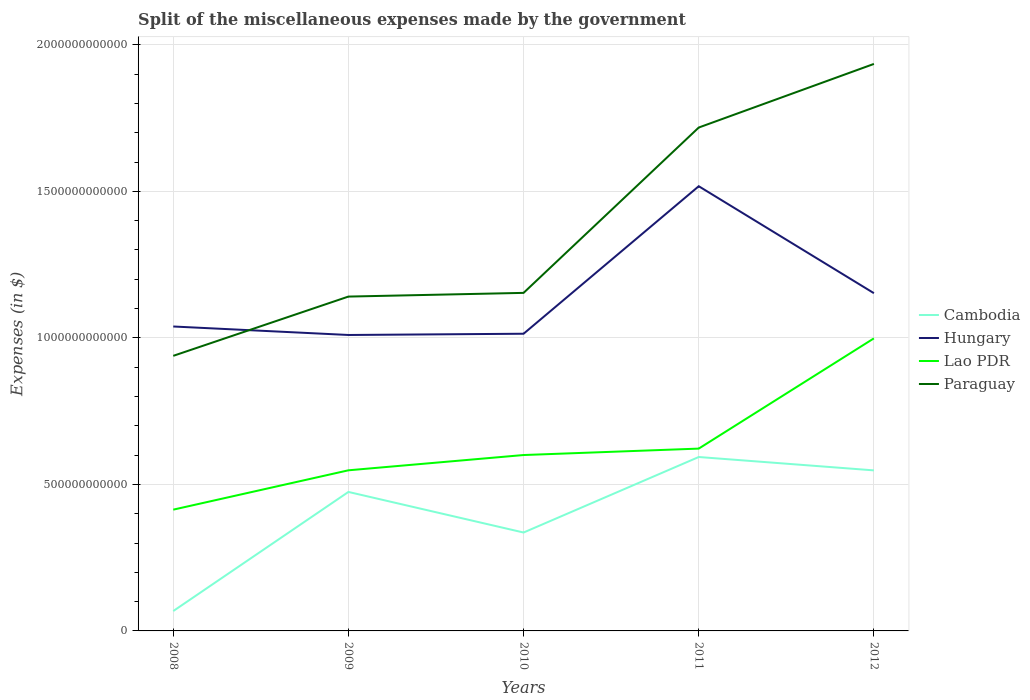Does the line corresponding to Lao PDR intersect with the line corresponding to Paraguay?
Make the answer very short. No. Is the number of lines equal to the number of legend labels?
Make the answer very short. Yes. Across all years, what is the maximum miscellaneous expenses made by the government in Paraguay?
Offer a very short reply. 9.39e+11. What is the total miscellaneous expenses made by the government in Cambodia in the graph?
Ensure brevity in your answer.  -5.26e+11. What is the difference between the highest and the second highest miscellaneous expenses made by the government in Cambodia?
Offer a terse response. 5.26e+11. Is the miscellaneous expenses made by the government in Paraguay strictly greater than the miscellaneous expenses made by the government in Lao PDR over the years?
Offer a terse response. No. How many years are there in the graph?
Your response must be concise. 5. What is the difference between two consecutive major ticks on the Y-axis?
Your answer should be very brief. 5.00e+11. Are the values on the major ticks of Y-axis written in scientific E-notation?
Give a very brief answer. No. Does the graph contain any zero values?
Provide a short and direct response. No. Where does the legend appear in the graph?
Offer a very short reply. Center right. How are the legend labels stacked?
Provide a short and direct response. Vertical. What is the title of the graph?
Offer a very short reply. Split of the miscellaneous expenses made by the government. What is the label or title of the X-axis?
Your answer should be very brief. Years. What is the label or title of the Y-axis?
Ensure brevity in your answer.  Expenses (in $). What is the Expenses (in $) of Cambodia in 2008?
Give a very brief answer. 6.78e+1. What is the Expenses (in $) of Hungary in 2008?
Offer a terse response. 1.04e+12. What is the Expenses (in $) of Lao PDR in 2008?
Offer a very short reply. 4.14e+11. What is the Expenses (in $) of Paraguay in 2008?
Your answer should be compact. 9.39e+11. What is the Expenses (in $) in Cambodia in 2009?
Ensure brevity in your answer.  4.74e+11. What is the Expenses (in $) of Hungary in 2009?
Your response must be concise. 1.01e+12. What is the Expenses (in $) of Lao PDR in 2009?
Your response must be concise. 5.48e+11. What is the Expenses (in $) of Paraguay in 2009?
Give a very brief answer. 1.14e+12. What is the Expenses (in $) of Cambodia in 2010?
Give a very brief answer. 3.36e+11. What is the Expenses (in $) in Hungary in 2010?
Offer a terse response. 1.01e+12. What is the Expenses (in $) in Lao PDR in 2010?
Provide a short and direct response. 6.00e+11. What is the Expenses (in $) in Paraguay in 2010?
Ensure brevity in your answer.  1.15e+12. What is the Expenses (in $) of Cambodia in 2011?
Give a very brief answer. 5.93e+11. What is the Expenses (in $) in Hungary in 2011?
Keep it short and to the point. 1.52e+12. What is the Expenses (in $) in Lao PDR in 2011?
Your answer should be compact. 6.22e+11. What is the Expenses (in $) in Paraguay in 2011?
Offer a very short reply. 1.72e+12. What is the Expenses (in $) of Cambodia in 2012?
Your answer should be compact. 5.48e+11. What is the Expenses (in $) of Hungary in 2012?
Provide a succinct answer. 1.15e+12. What is the Expenses (in $) in Lao PDR in 2012?
Provide a short and direct response. 9.98e+11. What is the Expenses (in $) of Paraguay in 2012?
Keep it short and to the point. 1.93e+12. Across all years, what is the maximum Expenses (in $) of Cambodia?
Offer a very short reply. 5.93e+11. Across all years, what is the maximum Expenses (in $) in Hungary?
Your answer should be very brief. 1.52e+12. Across all years, what is the maximum Expenses (in $) in Lao PDR?
Make the answer very short. 9.98e+11. Across all years, what is the maximum Expenses (in $) of Paraguay?
Your response must be concise. 1.93e+12. Across all years, what is the minimum Expenses (in $) in Cambodia?
Give a very brief answer. 6.78e+1. Across all years, what is the minimum Expenses (in $) of Hungary?
Ensure brevity in your answer.  1.01e+12. Across all years, what is the minimum Expenses (in $) of Lao PDR?
Provide a short and direct response. 4.14e+11. Across all years, what is the minimum Expenses (in $) of Paraguay?
Your response must be concise. 9.39e+11. What is the total Expenses (in $) in Cambodia in the graph?
Your answer should be compact. 2.02e+12. What is the total Expenses (in $) in Hungary in the graph?
Your answer should be very brief. 5.73e+12. What is the total Expenses (in $) of Lao PDR in the graph?
Give a very brief answer. 3.18e+12. What is the total Expenses (in $) of Paraguay in the graph?
Offer a very short reply. 6.89e+12. What is the difference between the Expenses (in $) of Cambodia in 2008 and that in 2009?
Make the answer very short. -4.06e+11. What is the difference between the Expenses (in $) of Hungary in 2008 and that in 2009?
Provide a succinct answer. 2.90e+1. What is the difference between the Expenses (in $) of Lao PDR in 2008 and that in 2009?
Ensure brevity in your answer.  -1.34e+11. What is the difference between the Expenses (in $) of Paraguay in 2008 and that in 2009?
Your answer should be compact. -2.02e+11. What is the difference between the Expenses (in $) in Cambodia in 2008 and that in 2010?
Your answer should be compact. -2.68e+11. What is the difference between the Expenses (in $) of Hungary in 2008 and that in 2010?
Keep it short and to the point. 2.47e+1. What is the difference between the Expenses (in $) of Lao PDR in 2008 and that in 2010?
Provide a short and direct response. -1.86e+11. What is the difference between the Expenses (in $) of Paraguay in 2008 and that in 2010?
Offer a very short reply. -2.15e+11. What is the difference between the Expenses (in $) in Cambodia in 2008 and that in 2011?
Make the answer very short. -5.26e+11. What is the difference between the Expenses (in $) in Hungary in 2008 and that in 2011?
Make the answer very short. -4.79e+11. What is the difference between the Expenses (in $) in Lao PDR in 2008 and that in 2011?
Your answer should be compact. -2.08e+11. What is the difference between the Expenses (in $) in Paraguay in 2008 and that in 2011?
Keep it short and to the point. -7.79e+11. What is the difference between the Expenses (in $) of Cambodia in 2008 and that in 2012?
Provide a short and direct response. -4.80e+11. What is the difference between the Expenses (in $) in Hungary in 2008 and that in 2012?
Offer a very short reply. -1.14e+11. What is the difference between the Expenses (in $) in Lao PDR in 2008 and that in 2012?
Offer a terse response. -5.85e+11. What is the difference between the Expenses (in $) of Paraguay in 2008 and that in 2012?
Make the answer very short. -9.96e+11. What is the difference between the Expenses (in $) of Cambodia in 2009 and that in 2010?
Offer a very short reply. 1.38e+11. What is the difference between the Expenses (in $) in Hungary in 2009 and that in 2010?
Provide a short and direct response. -4.23e+09. What is the difference between the Expenses (in $) in Lao PDR in 2009 and that in 2010?
Provide a short and direct response. -5.21e+1. What is the difference between the Expenses (in $) of Paraguay in 2009 and that in 2010?
Your answer should be compact. -1.26e+1. What is the difference between the Expenses (in $) of Cambodia in 2009 and that in 2011?
Keep it short and to the point. -1.19e+11. What is the difference between the Expenses (in $) in Hungary in 2009 and that in 2011?
Your response must be concise. -5.08e+11. What is the difference between the Expenses (in $) in Lao PDR in 2009 and that in 2011?
Your response must be concise. -7.41e+1. What is the difference between the Expenses (in $) in Paraguay in 2009 and that in 2011?
Ensure brevity in your answer.  -5.77e+11. What is the difference between the Expenses (in $) of Cambodia in 2009 and that in 2012?
Ensure brevity in your answer.  -7.35e+1. What is the difference between the Expenses (in $) in Hungary in 2009 and that in 2012?
Offer a terse response. -1.43e+11. What is the difference between the Expenses (in $) of Lao PDR in 2009 and that in 2012?
Your response must be concise. -4.50e+11. What is the difference between the Expenses (in $) of Paraguay in 2009 and that in 2012?
Ensure brevity in your answer.  -7.94e+11. What is the difference between the Expenses (in $) in Cambodia in 2010 and that in 2011?
Provide a succinct answer. -2.58e+11. What is the difference between the Expenses (in $) of Hungary in 2010 and that in 2011?
Provide a succinct answer. -5.03e+11. What is the difference between the Expenses (in $) of Lao PDR in 2010 and that in 2011?
Offer a terse response. -2.19e+1. What is the difference between the Expenses (in $) of Paraguay in 2010 and that in 2011?
Make the answer very short. -5.64e+11. What is the difference between the Expenses (in $) of Cambodia in 2010 and that in 2012?
Ensure brevity in your answer.  -2.12e+11. What is the difference between the Expenses (in $) in Hungary in 2010 and that in 2012?
Keep it short and to the point. -1.38e+11. What is the difference between the Expenses (in $) in Lao PDR in 2010 and that in 2012?
Provide a succinct answer. -3.98e+11. What is the difference between the Expenses (in $) in Paraguay in 2010 and that in 2012?
Offer a terse response. -7.81e+11. What is the difference between the Expenses (in $) of Cambodia in 2011 and that in 2012?
Keep it short and to the point. 4.56e+1. What is the difference between the Expenses (in $) in Hungary in 2011 and that in 2012?
Your answer should be very brief. 3.65e+11. What is the difference between the Expenses (in $) of Lao PDR in 2011 and that in 2012?
Provide a succinct answer. -3.76e+11. What is the difference between the Expenses (in $) in Paraguay in 2011 and that in 2012?
Your answer should be compact. -2.17e+11. What is the difference between the Expenses (in $) of Cambodia in 2008 and the Expenses (in $) of Hungary in 2009?
Offer a very short reply. -9.42e+11. What is the difference between the Expenses (in $) of Cambodia in 2008 and the Expenses (in $) of Lao PDR in 2009?
Your answer should be very brief. -4.80e+11. What is the difference between the Expenses (in $) of Cambodia in 2008 and the Expenses (in $) of Paraguay in 2009?
Your response must be concise. -1.07e+12. What is the difference between the Expenses (in $) of Hungary in 2008 and the Expenses (in $) of Lao PDR in 2009?
Your answer should be compact. 4.91e+11. What is the difference between the Expenses (in $) of Hungary in 2008 and the Expenses (in $) of Paraguay in 2009?
Make the answer very short. -1.02e+11. What is the difference between the Expenses (in $) of Lao PDR in 2008 and the Expenses (in $) of Paraguay in 2009?
Make the answer very short. -7.27e+11. What is the difference between the Expenses (in $) in Cambodia in 2008 and the Expenses (in $) in Hungary in 2010?
Ensure brevity in your answer.  -9.46e+11. What is the difference between the Expenses (in $) in Cambodia in 2008 and the Expenses (in $) in Lao PDR in 2010?
Your answer should be very brief. -5.32e+11. What is the difference between the Expenses (in $) of Cambodia in 2008 and the Expenses (in $) of Paraguay in 2010?
Provide a succinct answer. -1.09e+12. What is the difference between the Expenses (in $) of Hungary in 2008 and the Expenses (in $) of Lao PDR in 2010?
Offer a terse response. 4.39e+11. What is the difference between the Expenses (in $) of Hungary in 2008 and the Expenses (in $) of Paraguay in 2010?
Make the answer very short. -1.15e+11. What is the difference between the Expenses (in $) in Lao PDR in 2008 and the Expenses (in $) in Paraguay in 2010?
Offer a very short reply. -7.40e+11. What is the difference between the Expenses (in $) of Cambodia in 2008 and the Expenses (in $) of Hungary in 2011?
Offer a terse response. -1.45e+12. What is the difference between the Expenses (in $) in Cambodia in 2008 and the Expenses (in $) in Lao PDR in 2011?
Your answer should be compact. -5.54e+11. What is the difference between the Expenses (in $) of Cambodia in 2008 and the Expenses (in $) of Paraguay in 2011?
Offer a very short reply. -1.65e+12. What is the difference between the Expenses (in $) of Hungary in 2008 and the Expenses (in $) of Lao PDR in 2011?
Ensure brevity in your answer.  4.17e+11. What is the difference between the Expenses (in $) of Hungary in 2008 and the Expenses (in $) of Paraguay in 2011?
Give a very brief answer. -6.79e+11. What is the difference between the Expenses (in $) of Lao PDR in 2008 and the Expenses (in $) of Paraguay in 2011?
Provide a succinct answer. -1.30e+12. What is the difference between the Expenses (in $) of Cambodia in 2008 and the Expenses (in $) of Hungary in 2012?
Ensure brevity in your answer.  -1.08e+12. What is the difference between the Expenses (in $) in Cambodia in 2008 and the Expenses (in $) in Lao PDR in 2012?
Your answer should be very brief. -9.31e+11. What is the difference between the Expenses (in $) of Cambodia in 2008 and the Expenses (in $) of Paraguay in 2012?
Keep it short and to the point. -1.87e+12. What is the difference between the Expenses (in $) in Hungary in 2008 and the Expenses (in $) in Lao PDR in 2012?
Offer a very short reply. 4.05e+1. What is the difference between the Expenses (in $) of Hungary in 2008 and the Expenses (in $) of Paraguay in 2012?
Your response must be concise. -8.96e+11. What is the difference between the Expenses (in $) of Lao PDR in 2008 and the Expenses (in $) of Paraguay in 2012?
Offer a terse response. -1.52e+12. What is the difference between the Expenses (in $) of Cambodia in 2009 and the Expenses (in $) of Hungary in 2010?
Keep it short and to the point. -5.40e+11. What is the difference between the Expenses (in $) of Cambodia in 2009 and the Expenses (in $) of Lao PDR in 2010?
Offer a terse response. -1.26e+11. What is the difference between the Expenses (in $) in Cambodia in 2009 and the Expenses (in $) in Paraguay in 2010?
Offer a terse response. -6.79e+11. What is the difference between the Expenses (in $) in Hungary in 2009 and the Expenses (in $) in Lao PDR in 2010?
Provide a succinct answer. 4.10e+11. What is the difference between the Expenses (in $) in Hungary in 2009 and the Expenses (in $) in Paraguay in 2010?
Offer a very short reply. -1.44e+11. What is the difference between the Expenses (in $) of Lao PDR in 2009 and the Expenses (in $) of Paraguay in 2010?
Your answer should be compact. -6.05e+11. What is the difference between the Expenses (in $) of Cambodia in 2009 and the Expenses (in $) of Hungary in 2011?
Make the answer very short. -1.04e+12. What is the difference between the Expenses (in $) in Cambodia in 2009 and the Expenses (in $) in Lao PDR in 2011?
Give a very brief answer. -1.48e+11. What is the difference between the Expenses (in $) of Cambodia in 2009 and the Expenses (in $) of Paraguay in 2011?
Offer a very short reply. -1.24e+12. What is the difference between the Expenses (in $) of Hungary in 2009 and the Expenses (in $) of Lao PDR in 2011?
Your answer should be very brief. 3.88e+11. What is the difference between the Expenses (in $) of Hungary in 2009 and the Expenses (in $) of Paraguay in 2011?
Your answer should be very brief. -7.08e+11. What is the difference between the Expenses (in $) in Lao PDR in 2009 and the Expenses (in $) in Paraguay in 2011?
Ensure brevity in your answer.  -1.17e+12. What is the difference between the Expenses (in $) of Cambodia in 2009 and the Expenses (in $) of Hungary in 2012?
Provide a short and direct response. -6.78e+11. What is the difference between the Expenses (in $) in Cambodia in 2009 and the Expenses (in $) in Lao PDR in 2012?
Provide a succinct answer. -5.24e+11. What is the difference between the Expenses (in $) of Cambodia in 2009 and the Expenses (in $) of Paraguay in 2012?
Provide a short and direct response. -1.46e+12. What is the difference between the Expenses (in $) of Hungary in 2009 and the Expenses (in $) of Lao PDR in 2012?
Make the answer very short. 1.15e+1. What is the difference between the Expenses (in $) of Hungary in 2009 and the Expenses (in $) of Paraguay in 2012?
Provide a succinct answer. -9.25e+11. What is the difference between the Expenses (in $) of Lao PDR in 2009 and the Expenses (in $) of Paraguay in 2012?
Provide a succinct answer. -1.39e+12. What is the difference between the Expenses (in $) of Cambodia in 2010 and the Expenses (in $) of Hungary in 2011?
Keep it short and to the point. -1.18e+12. What is the difference between the Expenses (in $) in Cambodia in 2010 and the Expenses (in $) in Lao PDR in 2011?
Ensure brevity in your answer.  -2.86e+11. What is the difference between the Expenses (in $) of Cambodia in 2010 and the Expenses (in $) of Paraguay in 2011?
Your answer should be compact. -1.38e+12. What is the difference between the Expenses (in $) in Hungary in 2010 and the Expenses (in $) in Lao PDR in 2011?
Your answer should be compact. 3.92e+11. What is the difference between the Expenses (in $) of Hungary in 2010 and the Expenses (in $) of Paraguay in 2011?
Ensure brevity in your answer.  -7.04e+11. What is the difference between the Expenses (in $) in Lao PDR in 2010 and the Expenses (in $) in Paraguay in 2011?
Provide a short and direct response. -1.12e+12. What is the difference between the Expenses (in $) of Cambodia in 2010 and the Expenses (in $) of Hungary in 2012?
Provide a short and direct response. -8.17e+11. What is the difference between the Expenses (in $) of Cambodia in 2010 and the Expenses (in $) of Lao PDR in 2012?
Give a very brief answer. -6.63e+11. What is the difference between the Expenses (in $) in Cambodia in 2010 and the Expenses (in $) in Paraguay in 2012?
Ensure brevity in your answer.  -1.60e+12. What is the difference between the Expenses (in $) of Hungary in 2010 and the Expenses (in $) of Lao PDR in 2012?
Your answer should be compact. 1.58e+1. What is the difference between the Expenses (in $) in Hungary in 2010 and the Expenses (in $) in Paraguay in 2012?
Keep it short and to the point. -9.21e+11. What is the difference between the Expenses (in $) of Lao PDR in 2010 and the Expenses (in $) of Paraguay in 2012?
Your response must be concise. -1.33e+12. What is the difference between the Expenses (in $) in Cambodia in 2011 and the Expenses (in $) in Hungary in 2012?
Provide a succinct answer. -5.59e+11. What is the difference between the Expenses (in $) of Cambodia in 2011 and the Expenses (in $) of Lao PDR in 2012?
Ensure brevity in your answer.  -4.05e+11. What is the difference between the Expenses (in $) in Cambodia in 2011 and the Expenses (in $) in Paraguay in 2012?
Offer a terse response. -1.34e+12. What is the difference between the Expenses (in $) in Hungary in 2011 and the Expenses (in $) in Lao PDR in 2012?
Make the answer very short. 5.19e+11. What is the difference between the Expenses (in $) of Hungary in 2011 and the Expenses (in $) of Paraguay in 2012?
Keep it short and to the point. -4.17e+11. What is the difference between the Expenses (in $) of Lao PDR in 2011 and the Expenses (in $) of Paraguay in 2012?
Your answer should be compact. -1.31e+12. What is the average Expenses (in $) of Cambodia per year?
Your answer should be compact. 4.04e+11. What is the average Expenses (in $) of Hungary per year?
Give a very brief answer. 1.15e+12. What is the average Expenses (in $) of Lao PDR per year?
Offer a very short reply. 6.37e+11. What is the average Expenses (in $) of Paraguay per year?
Ensure brevity in your answer.  1.38e+12. In the year 2008, what is the difference between the Expenses (in $) of Cambodia and Expenses (in $) of Hungary?
Your answer should be very brief. -9.71e+11. In the year 2008, what is the difference between the Expenses (in $) in Cambodia and Expenses (in $) in Lao PDR?
Provide a short and direct response. -3.46e+11. In the year 2008, what is the difference between the Expenses (in $) in Cambodia and Expenses (in $) in Paraguay?
Offer a very short reply. -8.71e+11. In the year 2008, what is the difference between the Expenses (in $) in Hungary and Expenses (in $) in Lao PDR?
Keep it short and to the point. 6.25e+11. In the year 2008, what is the difference between the Expenses (in $) in Hungary and Expenses (in $) in Paraguay?
Offer a very short reply. 1.00e+11. In the year 2008, what is the difference between the Expenses (in $) in Lao PDR and Expenses (in $) in Paraguay?
Offer a very short reply. -5.25e+11. In the year 2009, what is the difference between the Expenses (in $) in Cambodia and Expenses (in $) in Hungary?
Provide a short and direct response. -5.36e+11. In the year 2009, what is the difference between the Expenses (in $) of Cambodia and Expenses (in $) of Lao PDR?
Your answer should be compact. -7.38e+1. In the year 2009, what is the difference between the Expenses (in $) in Cambodia and Expenses (in $) in Paraguay?
Keep it short and to the point. -6.67e+11. In the year 2009, what is the difference between the Expenses (in $) of Hungary and Expenses (in $) of Lao PDR?
Provide a short and direct response. 4.62e+11. In the year 2009, what is the difference between the Expenses (in $) of Hungary and Expenses (in $) of Paraguay?
Provide a short and direct response. -1.31e+11. In the year 2009, what is the difference between the Expenses (in $) of Lao PDR and Expenses (in $) of Paraguay?
Make the answer very short. -5.93e+11. In the year 2010, what is the difference between the Expenses (in $) of Cambodia and Expenses (in $) of Hungary?
Offer a terse response. -6.78e+11. In the year 2010, what is the difference between the Expenses (in $) in Cambodia and Expenses (in $) in Lao PDR?
Provide a short and direct response. -2.64e+11. In the year 2010, what is the difference between the Expenses (in $) in Cambodia and Expenses (in $) in Paraguay?
Give a very brief answer. -8.18e+11. In the year 2010, what is the difference between the Expenses (in $) of Hungary and Expenses (in $) of Lao PDR?
Your answer should be compact. 4.14e+11. In the year 2010, what is the difference between the Expenses (in $) of Hungary and Expenses (in $) of Paraguay?
Provide a succinct answer. -1.39e+11. In the year 2010, what is the difference between the Expenses (in $) of Lao PDR and Expenses (in $) of Paraguay?
Offer a terse response. -5.53e+11. In the year 2011, what is the difference between the Expenses (in $) in Cambodia and Expenses (in $) in Hungary?
Ensure brevity in your answer.  -9.24e+11. In the year 2011, what is the difference between the Expenses (in $) in Cambodia and Expenses (in $) in Lao PDR?
Provide a short and direct response. -2.87e+1. In the year 2011, what is the difference between the Expenses (in $) of Cambodia and Expenses (in $) of Paraguay?
Make the answer very short. -1.12e+12. In the year 2011, what is the difference between the Expenses (in $) in Hungary and Expenses (in $) in Lao PDR?
Keep it short and to the point. 8.95e+11. In the year 2011, what is the difference between the Expenses (in $) of Hungary and Expenses (in $) of Paraguay?
Offer a very short reply. -2.00e+11. In the year 2011, what is the difference between the Expenses (in $) of Lao PDR and Expenses (in $) of Paraguay?
Offer a terse response. -1.10e+12. In the year 2012, what is the difference between the Expenses (in $) in Cambodia and Expenses (in $) in Hungary?
Your answer should be very brief. -6.05e+11. In the year 2012, what is the difference between the Expenses (in $) of Cambodia and Expenses (in $) of Lao PDR?
Your answer should be very brief. -4.51e+11. In the year 2012, what is the difference between the Expenses (in $) of Cambodia and Expenses (in $) of Paraguay?
Offer a very short reply. -1.39e+12. In the year 2012, what is the difference between the Expenses (in $) of Hungary and Expenses (in $) of Lao PDR?
Provide a succinct answer. 1.54e+11. In the year 2012, what is the difference between the Expenses (in $) of Hungary and Expenses (in $) of Paraguay?
Make the answer very short. -7.82e+11. In the year 2012, what is the difference between the Expenses (in $) in Lao PDR and Expenses (in $) in Paraguay?
Your answer should be very brief. -9.36e+11. What is the ratio of the Expenses (in $) of Cambodia in 2008 to that in 2009?
Offer a terse response. 0.14. What is the ratio of the Expenses (in $) in Hungary in 2008 to that in 2009?
Your answer should be compact. 1.03. What is the ratio of the Expenses (in $) in Lao PDR in 2008 to that in 2009?
Your response must be concise. 0.76. What is the ratio of the Expenses (in $) in Paraguay in 2008 to that in 2009?
Provide a succinct answer. 0.82. What is the ratio of the Expenses (in $) of Cambodia in 2008 to that in 2010?
Keep it short and to the point. 0.2. What is the ratio of the Expenses (in $) of Hungary in 2008 to that in 2010?
Your answer should be compact. 1.02. What is the ratio of the Expenses (in $) in Lao PDR in 2008 to that in 2010?
Your response must be concise. 0.69. What is the ratio of the Expenses (in $) in Paraguay in 2008 to that in 2010?
Your answer should be very brief. 0.81. What is the ratio of the Expenses (in $) in Cambodia in 2008 to that in 2011?
Your answer should be compact. 0.11. What is the ratio of the Expenses (in $) of Hungary in 2008 to that in 2011?
Keep it short and to the point. 0.68. What is the ratio of the Expenses (in $) in Lao PDR in 2008 to that in 2011?
Your answer should be compact. 0.67. What is the ratio of the Expenses (in $) of Paraguay in 2008 to that in 2011?
Provide a succinct answer. 0.55. What is the ratio of the Expenses (in $) of Cambodia in 2008 to that in 2012?
Provide a short and direct response. 0.12. What is the ratio of the Expenses (in $) of Hungary in 2008 to that in 2012?
Your answer should be very brief. 0.9. What is the ratio of the Expenses (in $) of Lao PDR in 2008 to that in 2012?
Provide a succinct answer. 0.41. What is the ratio of the Expenses (in $) of Paraguay in 2008 to that in 2012?
Provide a short and direct response. 0.49. What is the ratio of the Expenses (in $) in Cambodia in 2009 to that in 2010?
Keep it short and to the point. 1.41. What is the ratio of the Expenses (in $) of Lao PDR in 2009 to that in 2010?
Offer a terse response. 0.91. What is the ratio of the Expenses (in $) in Cambodia in 2009 to that in 2011?
Your answer should be very brief. 0.8. What is the ratio of the Expenses (in $) of Hungary in 2009 to that in 2011?
Offer a very short reply. 0.67. What is the ratio of the Expenses (in $) of Lao PDR in 2009 to that in 2011?
Your answer should be compact. 0.88. What is the ratio of the Expenses (in $) in Paraguay in 2009 to that in 2011?
Make the answer very short. 0.66. What is the ratio of the Expenses (in $) in Cambodia in 2009 to that in 2012?
Provide a succinct answer. 0.87. What is the ratio of the Expenses (in $) of Hungary in 2009 to that in 2012?
Give a very brief answer. 0.88. What is the ratio of the Expenses (in $) in Lao PDR in 2009 to that in 2012?
Your answer should be compact. 0.55. What is the ratio of the Expenses (in $) in Paraguay in 2009 to that in 2012?
Your answer should be compact. 0.59. What is the ratio of the Expenses (in $) of Cambodia in 2010 to that in 2011?
Your answer should be compact. 0.57. What is the ratio of the Expenses (in $) of Hungary in 2010 to that in 2011?
Keep it short and to the point. 0.67. What is the ratio of the Expenses (in $) of Lao PDR in 2010 to that in 2011?
Your answer should be compact. 0.96. What is the ratio of the Expenses (in $) of Paraguay in 2010 to that in 2011?
Keep it short and to the point. 0.67. What is the ratio of the Expenses (in $) in Cambodia in 2010 to that in 2012?
Ensure brevity in your answer.  0.61. What is the ratio of the Expenses (in $) in Hungary in 2010 to that in 2012?
Your answer should be very brief. 0.88. What is the ratio of the Expenses (in $) of Lao PDR in 2010 to that in 2012?
Offer a terse response. 0.6. What is the ratio of the Expenses (in $) of Paraguay in 2010 to that in 2012?
Ensure brevity in your answer.  0.6. What is the ratio of the Expenses (in $) in Cambodia in 2011 to that in 2012?
Offer a very short reply. 1.08. What is the ratio of the Expenses (in $) of Hungary in 2011 to that in 2012?
Provide a short and direct response. 1.32. What is the ratio of the Expenses (in $) in Lao PDR in 2011 to that in 2012?
Your answer should be very brief. 0.62. What is the ratio of the Expenses (in $) of Paraguay in 2011 to that in 2012?
Make the answer very short. 0.89. What is the difference between the highest and the second highest Expenses (in $) of Cambodia?
Give a very brief answer. 4.56e+1. What is the difference between the highest and the second highest Expenses (in $) in Hungary?
Your answer should be compact. 3.65e+11. What is the difference between the highest and the second highest Expenses (in $) in Lao PDR?
Make the answer very short. 3.76e+11. What is the difference between the highest and the second highest Expenses (in $) in Paraguay?
Give a very brief answer. 2.17e+11. What is the difference between the highest and the lowest Expenses (in $) in Cambodia?
Your response must be concise. 5.26e+11. What is the difference between the highest and the lowest Expenses (in $) of Hungary?
Ensure brevity in your answer.  5.08e+11. What is the difference between the highest and the lowest Expenses (in $) in Lao PDR?
Provide a succinct answer. 5.85e+11. What is the difference between the highest and the lowest Expenses (in $) of Paraguay?
Provide a short and direct response. 9.96e+11. 